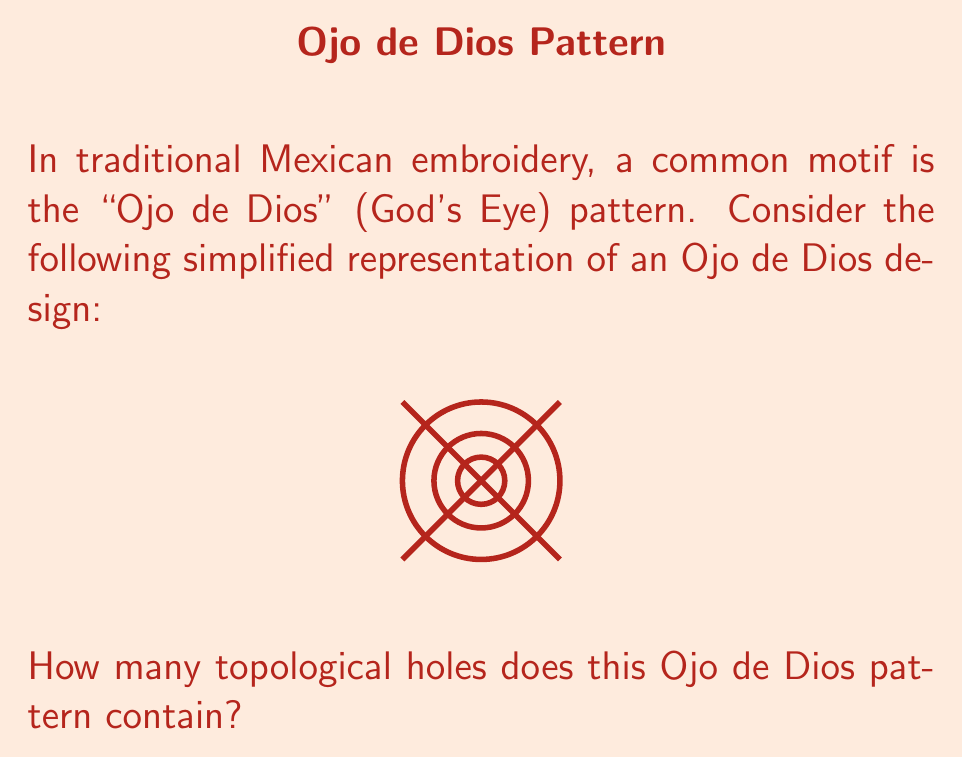Could you help me with this problem? To determine the number of topological holes in this Ojo de Dios pattern, we need to analyze its structure step-by-step:

1) First, recall that in topology, a hole is a fully enclosed region that is not filled.

2) Looking at the pattern, we can identify several circular components:
   - An outer circle
   - Two inner concentric circles

3) The space between each pair of circles forms a ring-like region. Each of these regions constitutes a topological hole.

4) We can count these holes:
   - One hole between the outer circle and the middle circle
   - One hole between the middle circle and the innermost circle

5) The innermost circle itself does not create a hole, as it's a filled region in this representation.

6) The crossed lines in the pattern do not create additional holes, as they don't fully enclose any new regions.

Therefore, we can conclude that this Ojo de Dios pattern contains 2 topological holes.

This analysis helps us appreciate the geometric complexity in traditional cultural designs, connecting mathematics with cultural heritage.
Answer: 2 